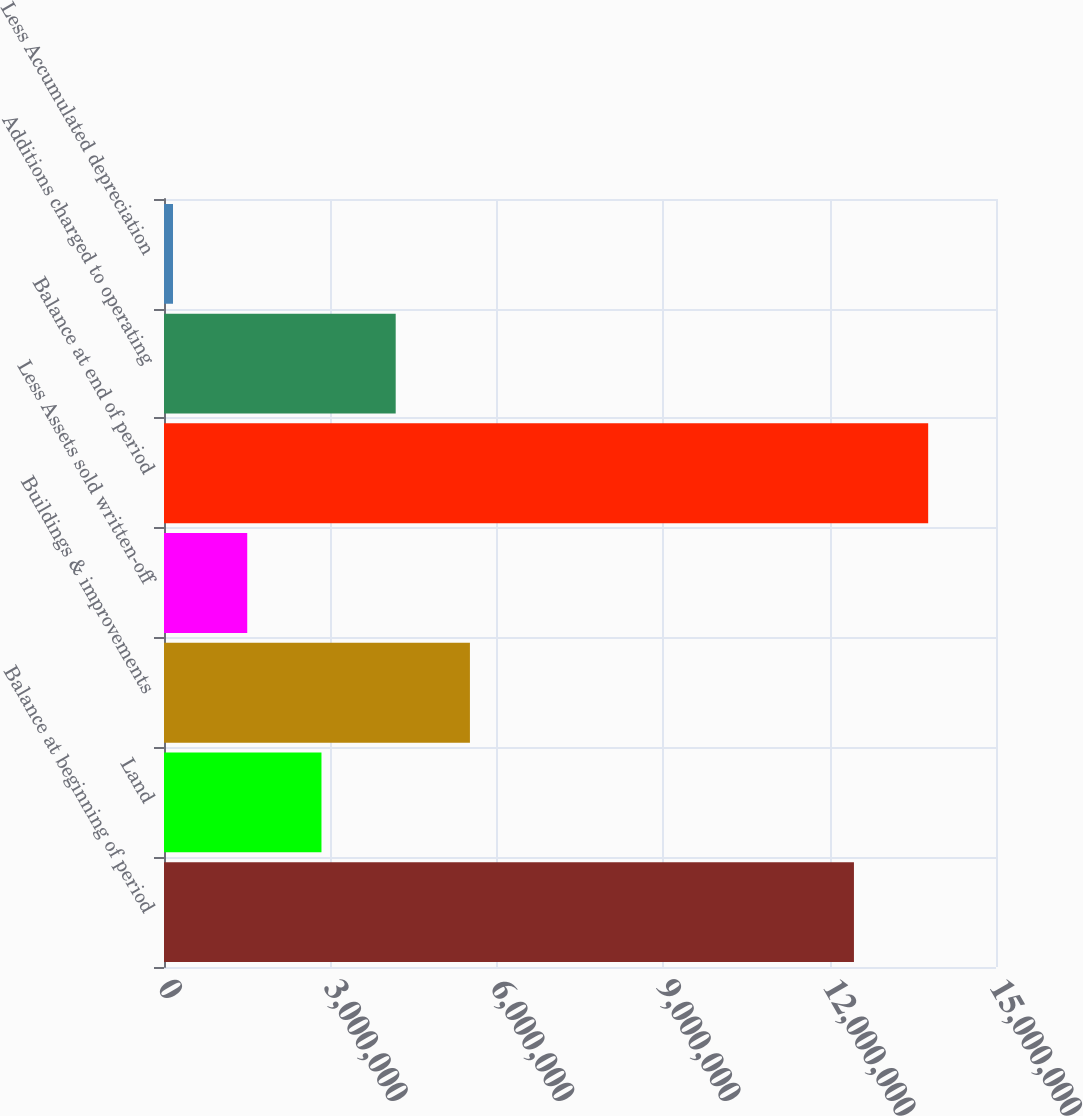Convert chart to OTSL. <chart><loc_0><loc_0><loc_500><loc_500><bar_chart><fcel>Balance at beginning of period<fcel>Land<fcel>Buildings & improvements<fcel>Less Assets sold written-off<fcel>Balance at end of period<fcel>Additions charged to operating<fcel>Less Accumulated depreciation<nl><fcel>1.24389e+07<fcel>2.83894e+06<fcel>5.51553e+06<fcel>1.50065e+06<fcel>1.37772e+07<fcel>4.17724e+06<fcel>162356<nl></chart> 